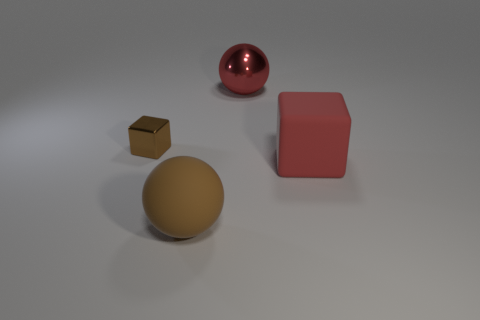There is a object that is in front of the thing on the right side of the big metallic object; what size is it?
Your response must be concise. Large. What number of brown metallic blocks have the same size as the red metal thing?
Keep it short and to the point. 0. Do the object that is on the left side of the large brown rubber object and the sphere that is behind the small cube have the same color?
Your response must be concise. No. Are there any red rubber objects behind the brown rubber object?
Your response must be concise. Yes. What is the color of the large thing that is left of the red rubber block and to the right of the big matte ball?
Offer a terse response. Red. Is there a large matte thing that has the same color as the big shiny object?
Your answer should be very brief. Yes. Is the material of the big red thing in front of the big shiny ball the same as the sphere that is behind the red matte cube?
Your answer should be very brief. No. What is the size of the brown object behind the large brown matte ball?
Give a very brief answer. Small. How big is the brown metallic cube?
Offer a terse response. Small. There is a thing left of the object that is in front of the matte object that is to the right of the large brown thing; how big is it?
Keep it short and to the point. Small. 